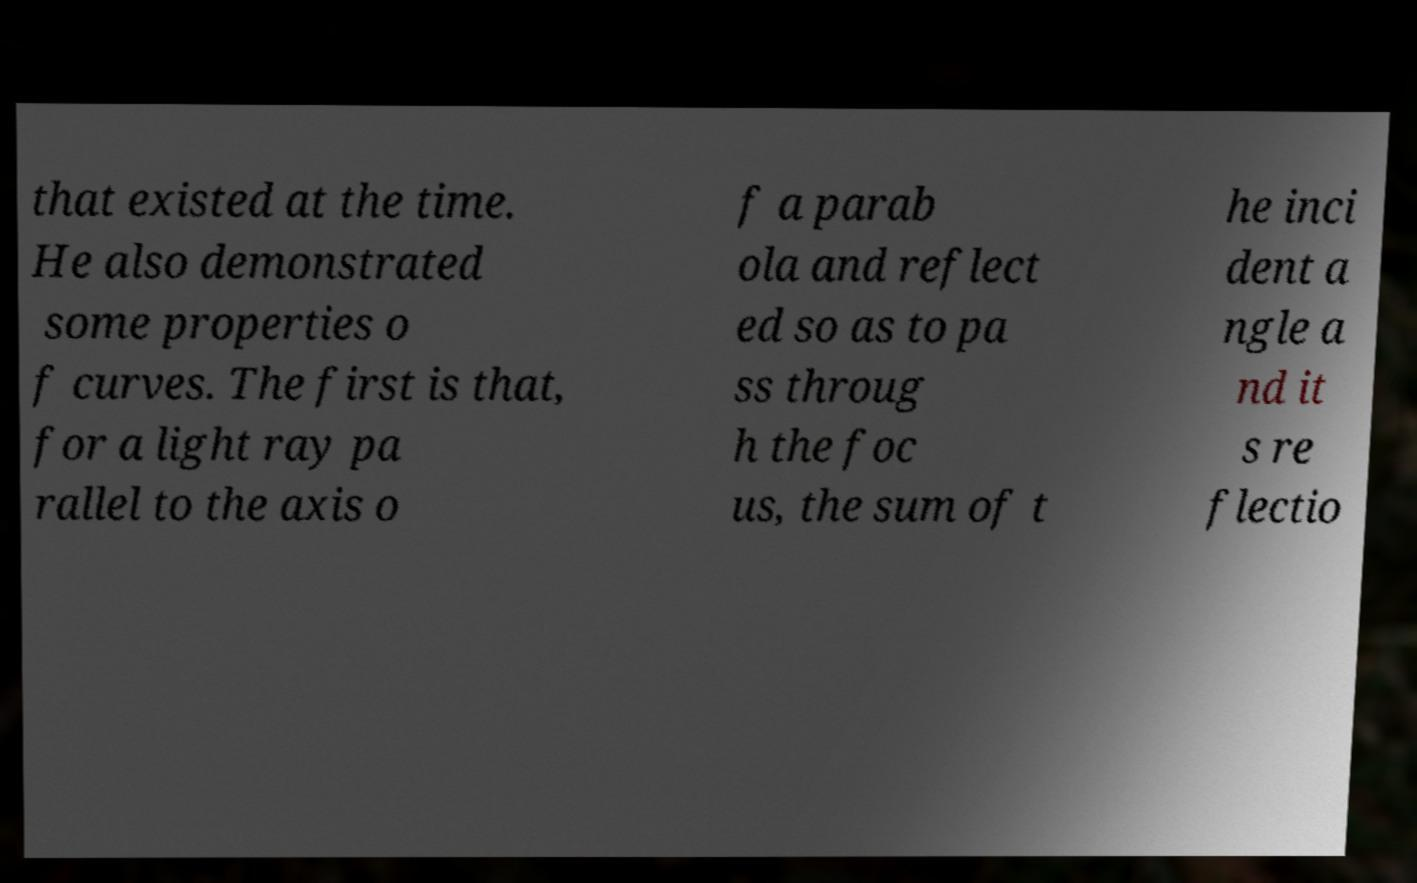Could you extract and type out the text from this image? that existed at the time. He also demonstrated some properties o f curves. The first is that, for a light ray pa rallel to the axis o f a parab ola and reflect ed so as to pa ss throug h the foc us, the sum of t he inci dent a ngle a nd it s re flectio 